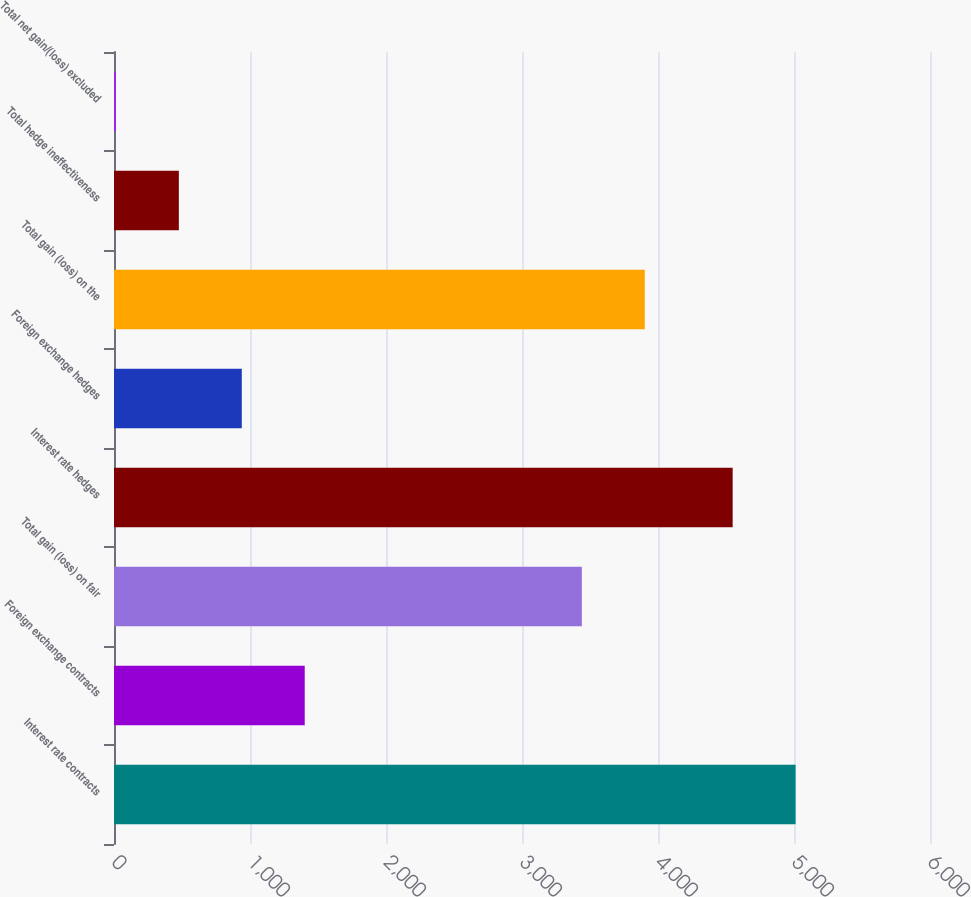Convert chart to OTSL. <chart><loc_0><loc_0><loc_500><loc_500><bar_chart><fcel>Interest rate contracts<fcel>Foreign exchange contracts<fcel>Total gain (loss) on fair<fcel>Interest rate hedges<fcel>Foreign exchange hedges<fcel>Total gain (loss) on the<fcel>Total hedge ineffectiveness<fcel>Total net gain/(loss) excluded<nl><fcel>5011.8<fcel>1402.4<fcel>3440<fcel>4549<fcel>939.6<fcel>3902.8<fcel>476.8<fcel>14<nl></chart> 